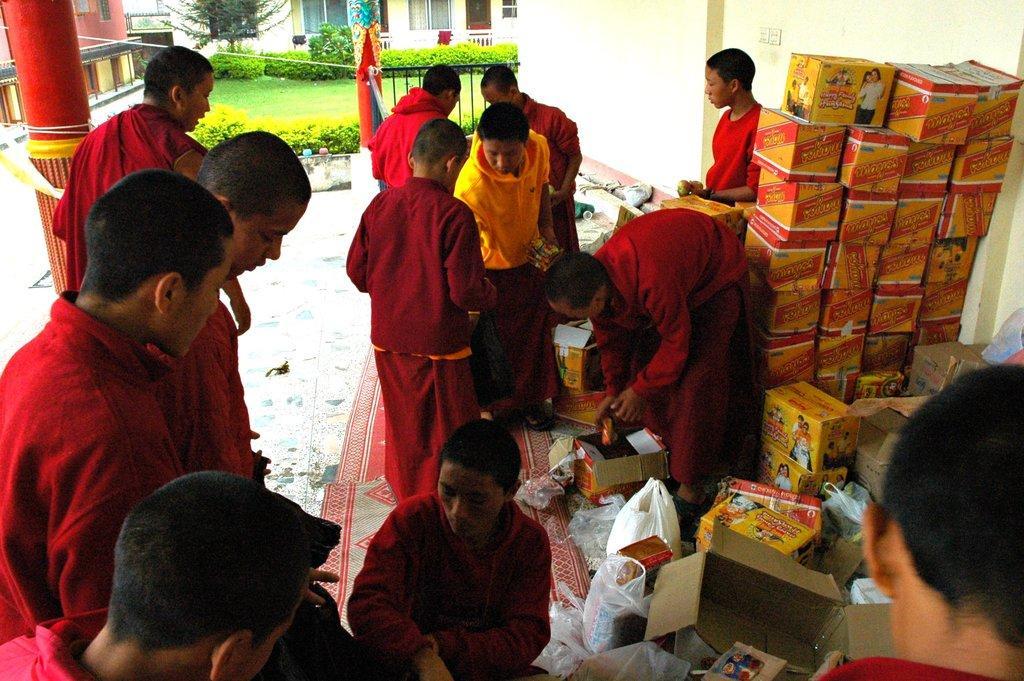Describe this image in one or two sentences. In this image I can see people, mats, pillar, cardboard boxes, windows, plants, grass, railing, buildings, plastic covers and objects.   